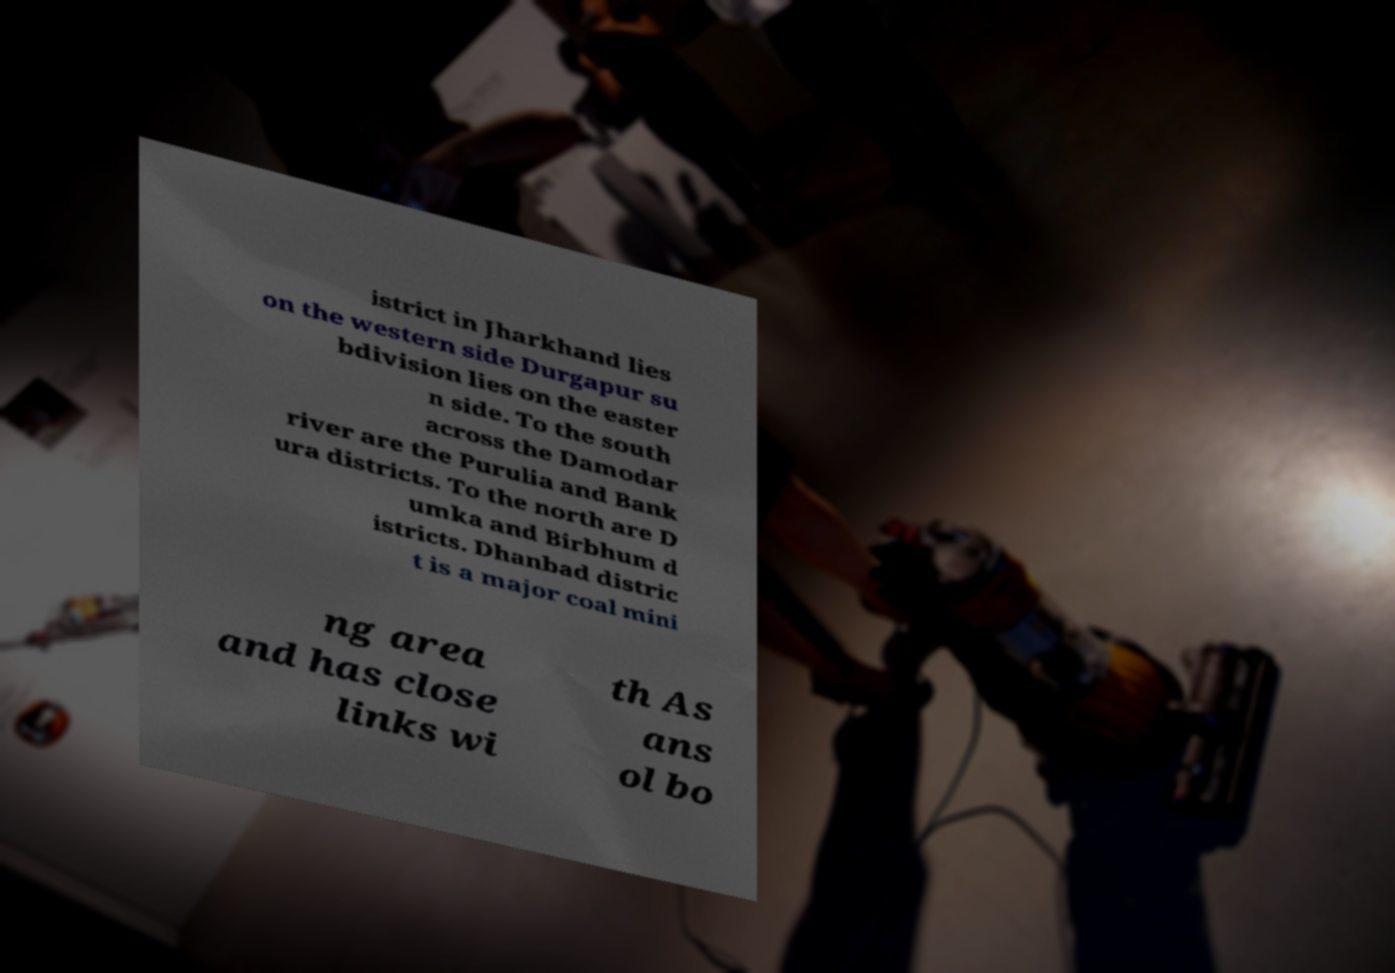Could you assist in decoding the text presented in this image and type it out clearly? istrict in Jharkhand lies on the western side Durgapur su bdivision lies on the easter n side. To the south across the Damodar river are the Purulia and Bank ura districts. To the north are D umka and Birbhum d istricts. Dhanbad distric t is a major coal mini ng area and has close links wi th As ans ol bo 